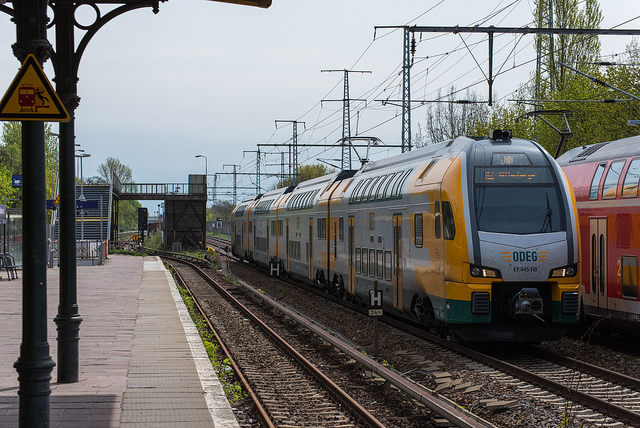<image>How are the trains powered? I am not sure on how the trains are powered. It can be electric or coal. How are the trains powered? The trains are powered by electricity. 